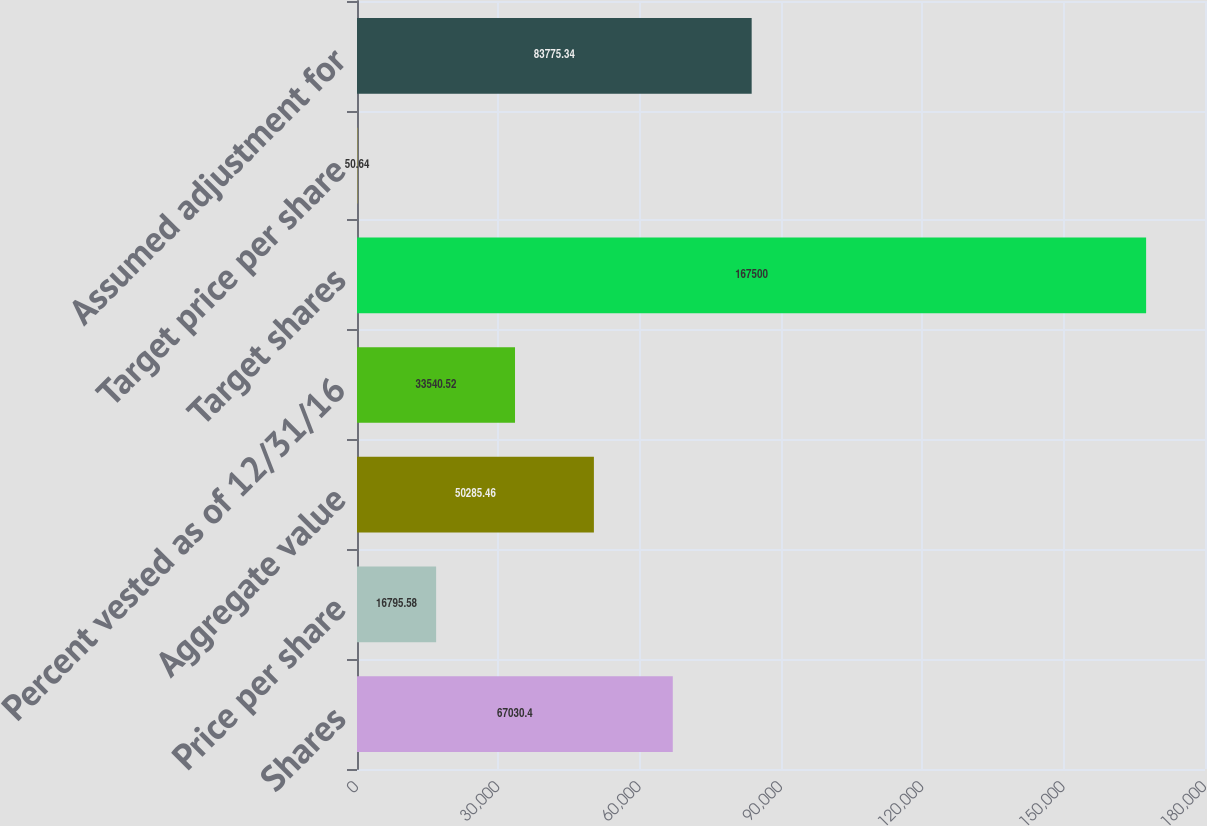<chart> <loc_0><loc_0><loc_500><loc_500><bar_chart><fcel>Shares<fcel>Price per share<fcel>Aggregate value<fcel>Percent vested as of 12/31/16<fcel>Target shares<fcel>Target price per share<fcel>Assumed adjustment for<nl><fcel>67030.4<fcel>16795.6<fcel>50285.5<fcel>33540.5<fcel>167500<fcel>50.64<fcel>83775.3<nl></chart> 